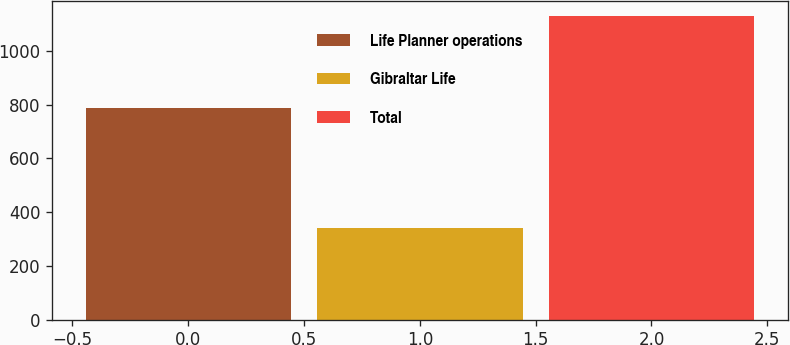Convert chart. <chart><loc_0><loc_0><loc_500><loc_500><bar_chart><fcel>Life Planner operations<fcel>Gibraltar Life<fcel>Total<nl><fcel>788<fcel>342<fcel>1130<nl></chart> 